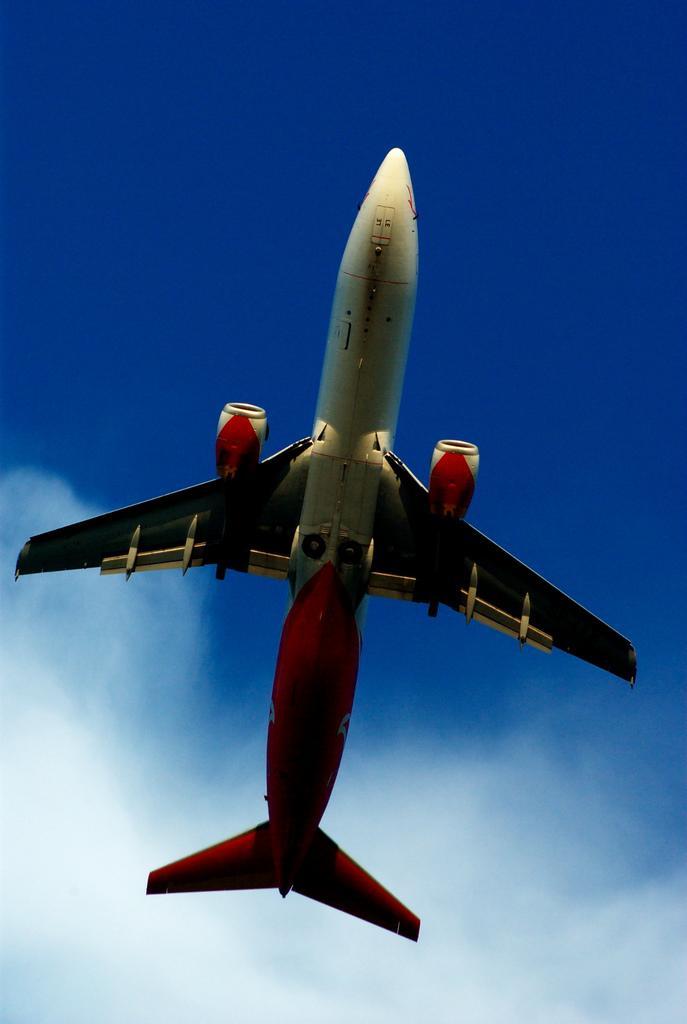Describe this image in one or two sentences. In this picture, we see the airplane in white and red color is flying in the sky. In the background, we see the sky, which is blue in color. 